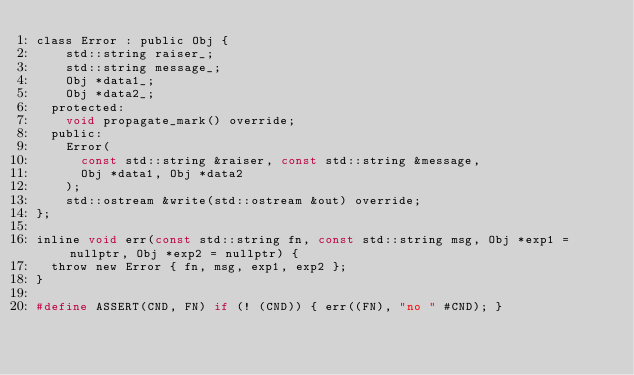Convert code to text. <code><loc_0><loc_0><loc_500><loc_500><_C_>class Error : public Obj {
		std::string raiser_;
		std::string message_;
		Obj *data1_;
		Obj *data2_;
	protected:
		void propagate_mark() override;
	public:
		Error(
			const std::string &raiser, const std::string &message,
			Obj *data1, Obj *data2
		);
		std::ostream &write(std::ostream &out) override;
};

inline void err(const std::string fn, const std::string msg, Obj *exp1 = nullptr, Obj *exp2 = nullptr) {
	throw new Error { fn, msg, exp1, exp2 };
}

#define ASSERT(CND, FN) if (! (CND)) { err((FN), "no " #CND); }

</code> 